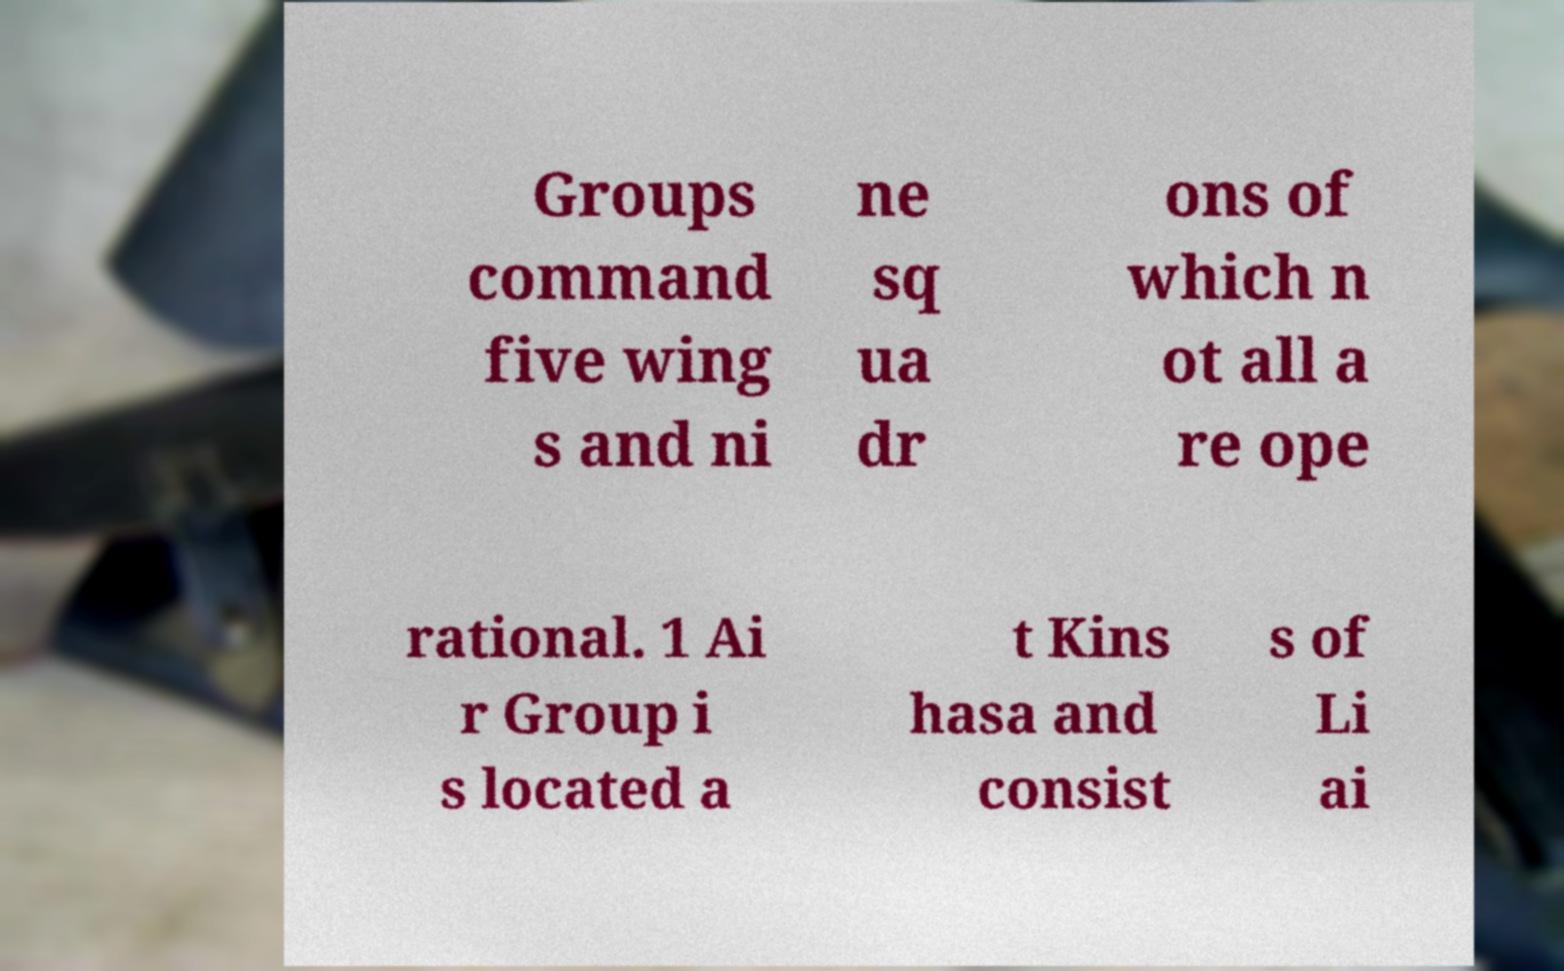For documentation purposes, I need the text within this image transcribed. Could you provide that? Groups command five wing s and ni ne sq ua dr ons of which n ot all a re ope rational. 1 Ai r Group i s located a t Kins hasa and consist s of Li ai 